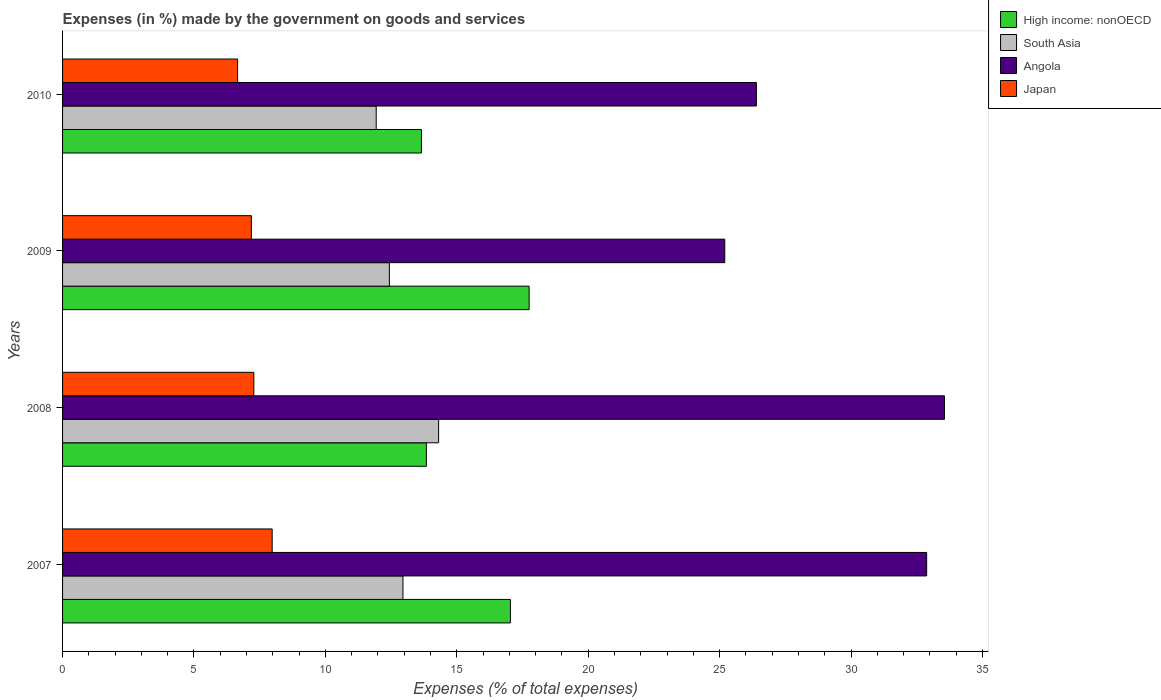Are the number of bars on each tick of the Y-axis equal?
Make the answer very short. Yes. In how many cases, is the number of bars for a given year not equal to the number of legend labels?
Offer a very short reply. 0. What is the percentage of expenses made by the government on goods and services in South Asia in 2009?
Your answer should be compact. 12.44. Across all years, what is the maximum percentage of expenses made by the government on goods and services in Japan?
Make the answer very short. 7.98. Across all years, what is the minimum percentage of expenses made by the government on goods and services in South Asia?
Give a very brief answer. 11.93. In which year was the percentage of expenses made by the government on goods and services in Angola minimum?
Keep it short and to the point. 2009. What is the total percentage of expenses made by the government on goods and services in Japan in the graph?
Offer a very short reply. 29.1. What is the difference between the percentage of expenses made by the government on goods and services in High income: nonOECD in 2007 and that in 2010?
Keep it short and to the point. 3.38. What is the difference between the percentage of expenses made by the government on goods and services in High income: nonOECD in 2009 and the percentage of expenses made by the government on goods and services in Japan in 2008?
Offer a terse response. 10.47. What is the average percentage of expenses made by the government on goods and services in South Asia per year?
Offer a very short reply. 12.91. In the year 2008, what is the difference between the percentage of expenses made by the government on goods and services in High income: nonOECD and percentage of expenses made by the government on goods and services in South Asia?
Offer a very short reply. -0.47. In how many years, is the percentage of expenses made by the government on goods and services in High income: nonOECD greater than 12 %?
Keep it short and to the point. 4. What is the ratio of the percentage of expenses made by the government on goods and services in Japan in 2007 to that in 2010?
Your response must be concise. 1.2. Is the difference between the percentage of expenses made by the government on goods and services in High income: nonOECD in 2009 and 2010 greater than the difference between the percentage of expenses made by the government on goods and services in South Asia in 2009 and 2010?
Give a very brief answer. Yes. What is the difference between the highest and the second highest percentage of expenses made by the government on goods and services in South Asia?
Your answer should be very brief. 1.36. What is the difference between the highest and the lowest percentage of expenses made by the government on goods and services in Japan?
Offer a very short reply. 1.32. Is the sum of the percentage of expenses made by the government on goods and services in High income: nonOECD in 2008 and 2010 greater than the maximum percentage of expenses made by the government on goods and services in South Asia across all years?
Keep it short and to the point. Yes. What does the 1st bar from the top in 2008 represents?
Your response must be concise. Japan. What does the 2nd bar from the bottom in 2009 represents?
Offer a very short reply. South Asia. Is it the case that in every year, the sum of the percentage of expenses made by the government on goods and services in High income: nonOECD and percentage of expenses made by the government on goods and services in Angola is greater than the percentage of expenses made by the government on goods and services in South Asia?
Keep it short and to the point. Yes. How many bars are there?
Offer a very short reply. 16. How many years are there in the graph?
Keep it short and to the point. 4. Are the values on the major ticks of X-axis written in scientific E-notation?
Your answer should be compact. No. Does the graph contain any zero values?
Your answer should be very brief. No. Does the graph contain grids?
Provide a succinct answer. No. Where does the legend appear in the graph?
Give a very brief answer. Top right. How many legend labels are there?
Make the answer very short. 4. What is the title of the graph?
Your answer should be very brief. Expenses (in %) made by the government on goods and services. What is the label or title of the X-axis?
Make the answer very short. Expenses (% of total expenses). What is the Expenses (% of total expenses) in High income: nonOECD in 2007?
Make the answer very short. 17.04. What is the Expenses (% of total expenses) of South Asia in 2007?
Offer a very short reply. 12.95. What is the Expenses (% of total expenses) of Angola in 2007?
Offer a terse response. 32.88. What is the Expenses (% of total expenses) of Japan in 2007?
Give a very brief answer. 7.98. What is the Expenses (% of total expenses) of High income: nonOECD in 2008?
Your answer should be compact. 13.84. What is the Expenses (% of total expenses) of South Asia in 2008?
Your answer should be compact. 14.31. What is the Expenses (% of total expenses) of Angola in 2008?
Ensure brevity in your answer.  33.56. What is the Expenses (% of total expenses) in Japan in 2008?
Ensure brevity in your answer.  7.28. What is the Expenses (% of total expenses) in High income: nonOECD in 2009?
Provide a short and direct response. 17.75. What is the Expenses (% of total expenses) in South Asia in 2009?
Keep it short and to the point. 12.44. What is the Expenses (% of total expenses) in Angola in 2009?
Make the answer very short. 25.2. What is the Expenses (% of total expenses) in Japan in 2009?
Your answer should be compact. 7.18. What is the Expenses (% of total expenses) in High income: nonOECD in 2010?
Your answer should be compact. 13.66. What is the Expenses (% of total expenses) in South Asia in 2010?
Keep it short and to the point. 11.93. What is the Expenses (% of total expenses) of Angola in 2010?
Provide a short and direct response. 26.4. What is the Expenses (% of total expenses) in Japan in 2010?
Your answer should be very brief. 6.66. Across all years, what is the maximum Expenses (% of total expenses) in High income: nonOECD?
Keep it short and to the point. 17.75. Across all years, what is the maximum Expenses (% of total expenses) in South Asia?
Your answer should be very brief. 14.31. Across all years, what is the maximum Expenses (% of total expenses) in Angola?
Provide a short and direct response. 33.56. Across all years, what is the maximum Expenses (% of total expenses) in Japan?
Keep it short and to the point. 7.98. Across all years, what is the minimum Expenses (% of total expenses) of High income: nonOECD?
Offer a terse response. 13.66. Across all years, what is the minimum Expenses (% of total expenses) in South Asia?
Your answer should be compact. 11.93. Across all years, what is the minimum Expenses (% of total expenses) in Angola?
Your answer should be compact. 25.2. Across all years, what is the minimum Expenses (% of total expenses) of Japan?
Your response must be concise. 6.66. What is the total Expenses (% of total expenses) in High income: nonOECD in the graph?
Provide a short and direct response. 62.29. What is the total Expenses (% of total expenses) in South Asia in the graph?
Provide a short and direct response. 51.63. What is the total Expenses (% of total expenses) of Angola in the graph?
Offer a very short reply. 118.03. What is the total Expenses (% of total expenses) of Japan in the graph?
Make the answer very short. 29.1. What is the difference between the Expenses (% of total expenses) of High income: nonOECD in 2007 and that in 2008?
Offer a terse response. 3.2. What is the difference between the Expenses (% of total expenses) of South Asia in 2007 and that in 2008?
Provide a short and direct response. -1.36. What is the difference between the Expenses (% of total expenses) in Angola in 2007 and that in 2008?
Give a very brief answer. -0.68. What is the difference between the Expenses (% of total expenses) of Japan in 2007 and that in 2008?
Make the answer very short. 0.7. What is the difference between the Expenses (% of total expenses) of High income: nonOECD in 2007 and that in 2009?
Offer a very short reply. -0.71. What is the difference between the Expenses (% of total expenses) in South Asia in 2007 and that in 2009?
Make the answer very short. 0.52. What is the difference between the Expenses (% of total expenses) in Angola in 2007 and that in 2009?
Provide a short and direct response. 7.68. What is the difference between the Expenses (% of total expenses) in Japan in 2007 and that in 2009?
Keep it short and to the point. 0.79. What is the difference between the Expenses (% of total expenses) in High income: nonOECD in 2007 and that in 2010?
Provide a short and direct response. 3.38. What is the difference between the Expenses (% of total expenses) of South Asia in 2007 and that in 2010?
Ensure brevity in your answer.  1.02. What is the difference between the Expenses (% of total expenses) in Angola in 2007 and that in 2010?
Your response must be concise. 6.48. What is the difference between the Expenses (% of total expenses) in Japan in 2007 and that in 2010?
Offer a terse response. 1.32. What is the difference between the Expenses (% of total expenses) in High income: nonOECD in 2008 and that in 2009?
Provide a short and direct response. -3.91. What is the difference between the Expenses (% of total expenses) in South Asia in 2008 and that in 2009?
Your response must be concise. 1.87. What is the difference between the Expenses (% of total expenses) of Angola in 2008 and that in 2009?
Provide a succinct answer. 8.36. What is the difference between the Expenses (% of total expenses) in Japan in 2008 and that in 2009?
Keep it short and to the point. 0.09. What is the difference between the Expenses (% of total expenses) in High income: nonOECD in 2008 and that in 2010?
Your answer should be very brief. 0.19. What is the difference between the Expenses (% of total expenses) in South Asia in 2008 and that in 2010?
Offer a very short reply. 2.37. What is the difference between the Expenses (% of total expenses) of Angola in 2008 and that in 2010?
Keep it short and to the point. 7.16. What is the difference between the Expenses (% of total expenses) in Japan in 2008 and that in 2010?
Keep it short and to the point. 0.62. What is the difference between the Expenses (% of total expenses) of High income: nonOECD in 2009 and that in 2010?
Offer a very short reply. 4.1. What is the difference between the Expenses (% of total expenses) of South Asia in 2009 and that in 2010?
Make the answer very short. 0.5. What is the difference between the Expenses (% of total expenses) in Angola in 2009 and that in 2010?
Provide a short and direct response. -1.2. What is the difference between the Expenses (% of total expenses) in Japan in 2009 and that in 2010?
Offer a terse response. 0.52. What is the difference between the Expenses (% of total expenses) in High income: nonOECD in 2007 and the Expenses (% of total expenses) in South Asia in 2008?
Give a very brief answer. 2.73. What is the difference between the Expenses (% of total expenses) of High income: nonOECD in 2007 and the Expenses (% of total expenses) of Angola in 2008?
Offer a very short reply. -16.52. What is the difference between the Expenses (% of total expenses) of High income: nonOECD in 2007 and the Expenses (% of total expenses) of Japan in 2008?
Provide a succinct answer. 9.76. What is the difference between the Expenses (% of total expenses) of South Asia in 2007 and the Expenses (% of total expenses) of Angola in 2008?
Your answer should be compact. -20.6. What is the difference between the Expenses (% of total expenses) in South Asia in 2007 and the Expenses (% of total expenses) in Japan in 2008?
Offer a very short reply. 5.67. What is the difference between the Expenses (% of total expenses) in Angola in 2007 and the Expenses (% of total expenses) in Japan in 2008?
Make the answer very short. 25.6. What is the difference between the Expenses (% of total expenses) in High income: nonOECD in 2007 and the Expenses (% of total expenses) in South Asia in 2009?
Make the answer very short. 4.6. What is the difference between the Expenses (% of total expenses) in High income: nonOECD in 2007 and the Expenses (% of total expenses) in Angola in 2009?
Your answer should be very brief. -8.16. What is the difference between the Expenses (% of total expenses) in High income: nonOECD in 2007 and the Expenses (% of total expenses) in Japan in 2009?
Your response must be concise. 9.86. What is the difference between the Expenses (% of total expenses) in South Asia in 2007 and the Expenses (% of total expenses) in Angola in 2009?
Provide a short and direct response. -12.24. What is the difference between the Expenses (% of total expenses) in South Asia in 2007 and the Expenses (% of total expenses) in Japan in 2009?
Provide a succinct answer. 5.77. What is the difference between the Expenses (% of total expenses) in Angola in 2007 and the Expenses (% of total expenses) in Japan in 2009?
Offer a very short reply. 25.69. What is the difference between the Expenses (% of total expenses) in High income: nonOECD in 2007 and the Expenses (% of total expenses) in South Asia in 2010?
Provide a succinct answer. 5.11. What is the difference between the Expenses (% of total expenses) in High income: nonOECD in 2007 and the Expenses (% of total expenses) in Angola in 2010?
Your answer should be compact. -9.36. What is the difference between the Expenses (% of total expenses) in High income: nonOECD in 2007 and the Expenses (% of total expenses) in Japan in 2010?
Give a very brief answer. 10.38. What is the difference between the Expenses (% of total expenses) of South Asia in 2007 and the Expenses (% of total expenses) of Angola in 2010?
Offer a terse response. -13.45. What is the difference between the Expenses (% of total expenses) of South Asia in 2007 and the Expenses (% of total expenses) of Japan in 2010?
Your response must be concise. 6.29. What is the difference between the Expenses (% of total expenses) of Angola in 2007 and the Expenses (% of total expenses) of Japan in 2010?
Keep it short and to the point. 26.22. What is the difference between the Expenses (% of total expenses) in High income: nonOECD in 2008 and the Expenses (% of total expenses) in South Asia in 2009?
Offer a terse response. 1.41. What is the difference between the Expenses (% of total expenses) of High income: nonOECD in 2008 and the Expenses (% of total expenses) of Angola in 2009?
Your response must be concise. -11.35. What is the difference between the Expenses (% of total expenses) of High income: nonOECD in 2008 and the Expenses (% of total expenses) of Japan in 2009?
Offer a terse response. 6.66. What is the difference between the Expenses (% of total expenses) of South Asia in 2008 and the Expenses (% of total expenses) of Angola in 2009?
Give a very brief answer. -10.89. What is the difference between the Expenses (% of total expenses) in South Asia in 2008 and the Expenses (% of total expenses) in Japan in 2009?
Ensure brevity in your answer.  7.13. What is the difference between the Expenses (% of total expenses) of Angola in 2008 and the Expenses (% of total expenses) of Japan in 2009?
Offer a very short reply. 26.37. What is the difference between the Expenses (% of total expenses) in High income: nonOECD in 2008 and the Expenses (% of total expenses) in South Asia in 2010?
Provide a succinct answer. 1.91. What is the difference between the Expenses (% of total expenses) of High income: nonOECD in 2008 and the Expenses (% of total expenses) of Angola in 2010?
Give a very brief answer. -12.56. What is the difference between the Expenses (% of total expenses) in High income: nonOECD in 2008 and the Expenses (% of total expenses) in Japan in 2010?
Provide a succinct answer. 7.18. What is the difference between the Expenses (% of total expenses) of South Asia in 2008 and the Expenses (% of total expenses) of Angola in 2010?
Make the answer very short. -12.09. What is the difference between the Expenses (% of total expenses) of South Asia in 2008 and the Expenses (% of total expenses) of Japan in 2010?
Your answer should be compact. 7.65. What is the difference between the Expenses (% of total expenses) of Angola in 2008 and the Expenses (% of total expenses) of Japan in 2010?
Offer a terse response. 26.9. What is the difference between the Expenses (% of total expenses) of High income: nonOECD in 2009 and the Expenses (% of total expenses) of South Asia in 2010?
Keep it short and to the point. 5.82. What is the difference between the Expenses (% of total expenses) in High income: nonOECD in 2009 and the Expenses (% of total expenses) in Angola in 2010?
Keep it short and to the point. -8.65. What is the difference between the Expenses (% of total expenses) in High income: nonOECD in 2009 and the Expenses (% of total expenses) in Japan in 2010?
Give a very brief answer. 11.09. What is the difference between the Expenses (% of total expenses) of South Asia in 2009 and the Expenses (% of total expenses) of Angola in 2010?
Give a very brief answer. -13.96. What is the difference between the Expenses (% of total expenses) of South Asia in 2009 and the Expenses (% of total expenses) of Japan in 2010?
Ensure brevity in your answer.  5.78. What is the difference between the Expenses (% of total expenses) of Angola in 2009 and the Expenses (% of total expenses) of Japan in 2010?
Your response must be concise. 18.54. What is the average Expenses (% of total expenses) in High income: nonOECD per year?
Provide a short and direct response. 15.57. What is the average Expenses (% of total expenses) of South Asia per year?
Provide a short and direct response. 12.91. What is the average Expenses (% of total expenses) of Angola per year?
Make the answer very short. 29.51. What is the average Expenses (% of total expenses) of Japan per year?
Provide a short and direct response. 7.27. In the year 2007, what is the difference between the Expenses (% of total expenses) in High income: nonOECD and Expenses (% of total expenses) in South Asia?
Offer a terse response. 4.09. In the year 2007, what is the difference between the Expenses (% of total expenses) in High income: nonOECD and Expenses (% of total expenses) in Angola?
Offer a very short reply. -15.84. In the year 2007, what is the difference between the Expenses (% of total expenses) in High income: nonOECD and Expenses (% of total expenses) in Japan?
Ensure brevity in your answer.  9.06. In the year 2007, what is the difference between the Expenses (% of total expenses) in South Asia and Expenses (% of total expenses) in Angola?
Offer a terse response. -19.93. In the year 2007, what is the difference between the Expenses (% of total expenses) of South Asia and Expenses (% of total expenses) of Japan?
Provide a short and direct response. 4.98. In the year 2007, what is the difference between the Expenses (% of total expenses) of Angola and Expenses (% of total expenses) of Japan?
Provide a short and direct response. 24.9. In the year 2008, what is the difference between the Expenses (% of total expenses) of High income: nonOECD and Expenses (% of total expenses) of South Asia?
Your answer should be very brief. -0.47. In the year 2008, what is the difference between the Expenses (% of total expenses) of High income: nonOECD and Expenses (% of total expenses) of Angola?
Provide a succinct answer. -19.71. In the year 2008, what is the difference between the Expenses (% of total expenses) of High income: nonOECD and Expenses (% of total expenses) of Japan?
Give a very brief answer. 6.57. In the year 2008, what is the difference between the Expenses (% of total expenses) in South Asia and Expenses (% of total expenses) in Angola?
Ensure brevity in your answer.  -19.25. In the year 2008, what is the difference between the Expenses (% of total expenses) in South Asia and Expenses (% of total expenses) in Japan?
Provide a succinct answer. 7.03. In the year 2008, what is the difference between the Expenses (% of total expenses) in Angola and Expenses (% of total expenses) in Japan?
Your answer should be very brief. 26.28. In the year 2009, what is the difference between the Expenses (% of total expenses) of High income: nonOECD and Expenses (% of total expenses) of South Asia?
Your answer should be compact. 5.32. In the year 2009, what is the difference between the Expenses (% of total expenses) in High income: nonOECD and Expenses (% of total expenses) in Angola?
Your answer should be very brief. -7.44. In the year 2009, what is the difference between the Expenses (% of total expenses) of High income: nonOECD and Expenses (% of total expenses) of Japan?
Your response must be concise. 10.57. In the year 2009, what is the difference between the Expenses (% of total expenses) of South Asia and Expenses (% of total expenses) of Angola?
Your response must be concise. -12.76. In the year 2009, what is the difference between the Expenses (% of total expenses) of South Asia and Expenses (% of total expenses) of Japan?
Provide a succinct answer. 5.25. In the year 2009, what is the difference between the Expenses (% of total expenses) of Angola and Expenses (% of total expenses) of Japan?
Give a very brief answer. 18.01. In the year 2010, what is the difference between the Expenses (% of total expenses) of High income: nonOECD and Expenses (% of total expenses) of South Asia?
Provide a short and direct response. 1.72. In the year 2010, what is the difference between the Expenses (% of total expenses) in High income: nonOECD and Expenses (% of total expenses) in Angola?
Your answer should be very brief. -12.74. In the year 2010, what is the difference between the Expenses (% of total expenses) of High income: nonOECD and Expenses (% of total expenses) of Japan?
Give a very brief answer. 7. In the year 2010, what is the difference between the Expenses (% of total expenses) in South Asia and Expenses (% of total expenses) in Angola?
Give a very brief answer. -14.47. In the year 2010, what is the difference between the Expenses (% of total expenses) in South Asia and Expenses (% of total expenses) in Japan?
Provide a short and direct response. 5.27. In the year 2010, what is the difference between the Expenses (% of total expenses) of Angola and Expenses (% of total expenses) of Japan?
Give a very brief answer. 19.74. What is the ratio of the Expenses (% of total expenses) of High income: nonOECD in 2007 to that in 2008?
Your response must be concise. 1.23. What is the ratio of the Expenses (% of total expenses) of South Asia in 2007 to that in 2008?
Make the answer very short. 0.91. What is the ratio of the Expenses (% of total expenses) of Angola in 2007 to that in 2008?
Your answer should be very brief. 0.98. What is the ratio of the Expenses (% of total expenses) of Japan in 2007 to that in 2008?
Provide a succinct answer. 1.1. What is the ratio of the Expenses (% of total expenses) in High income: nonOECD in 2007 to that in 2009?
Provide a succinct answer. 0.96. What is the ratio of the Expenses (% of total expenses) of South Asia in 2007 to that in 2009?
Your response must be concise. 1.04. What is the ratio of the Expenses (% of total expenses) of Angola in 2007 to that in 2009?
Give a very brief answer. 1.3. What is the ratio of the Expenses (% of total expenses) in Japan in 2007 to that in 2009?
Offer a terse response. 1.11. What is the ratio of the Expenses (% of total expenses) of High income: nonOECD in 2007 to that in 2010?
Your response must be concise. 1.25. What is the ratio of the Expenses (% of total expenses) of South Asia in 2007 to that in 2010?
Ensure brevity in your answer.  1.09. What is the ratio of the Expenses (% of total expenses) in Angola in 2007 to that in 2010?
Offer a very short reply. 1.25. What is the ratio of the Expenses (% of total expenses) in Japan in 2007 to that in 2010?
Offer a terse response. 1.2. What is the ratio of the Expenses (% of total expenses) in High income: nonOECD in 2008 to that in 2009?
Ensure brevity in your answer.  0.78. What is the ratio of the Expenses (% of total expenses) of South Asia in 2008 to that in 2009?
Offer a terse response. 1.15. What is the ratio of the Expenses (% of total expenses) of Angola in 2008 to that in 2009?
Give a very brief answer. 1.33. What is the ratio of the Expenses (% of total expenses) of Japan in 2008 to that in 2009?
Give a very brief answer. 1.01. What is the ratio of the Expenses (% of total expenses) in High income: nonOECD in 2008 to that in 2010?
Give a very brief answer. 1.01. What is the ratio of the Expenses (% of total expenses) of South Asia in 2008 to that in 2010?
Provide a succinct answer. 1.2. What is the ratio of the Expenses (% of total expenses) of Angola in 2008 to that in 2010?
Ensure brevity in your answer.  1.27. What is the ratio of the Expenses (% of total expenses) in Japan in 2008 to that in 2010?
Offer a terse response. 1.09. What is the ratio of the Expenses (% of total expenses) in South Asia in 2009 to that in 2010?
Your response must be concise. 1.04. What is the ratio of the Expenses (% of total expenses) of Angola in 2009 to that in 2010?
Make the answer very short. 0.95. What is the ratio of the Expenses (% of total expenses) of Japan in 2009 to that in 2010?
Keep it short and to the point. 1.08. What is the difference between the highest and the second highest Expenses (% of total expenses) in High income: nonOECD?
Provide a short and direct response. 0.71. What is the difference between the highest and the second highest Expenses (% of total expenses) in South Asia?
Give a very brief answer. 1.36. What is the difference between the highest and the second highest Expenses (% of total expenses) of Angola?
Provide a short and direct response. 0.68. What is the difference between the highest and the second highest Expenses (% of total expenses) in Japan?
Offer a terse response. 0.7. What is the difference between the highest and the lowest Expenses (% of total expenses) of High income: nonOECD?
Give a very brief answer. 4.1. What is the difference between the highest and the lowest Expenses (% of total expenses) of South Asia?
Keep it short and to the point. 2.37. What is the difference between the highest and the lowest Expenses (% of total expenses) of Angola?
Your answer should be very brief. 8.36. What is the difference between the highest and the lowest Expenses (% of total expenses) in Japan?
Provide a succinct answer. 1.32. 